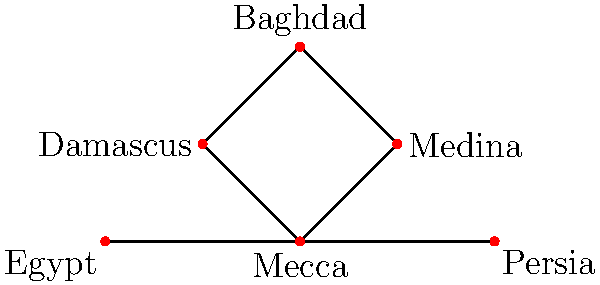In the graph representing the spread of early Islamic teachings, what is the minimum number of cities that need to be removed to disconnect Mecca from Baghdad? To solve this problem, we need to analyze the graph and find the minimum cut between Mecca and Baghdad. Let's approach this step-by-step:

1. Identify the paths from Mecca to Baghdad:
   a. Mecca → Medina → Baghdad
   b. Mecca → Damascus → Baghdad

2. Observe that there are two independent paths from Mecca to Baghdad.

3. According to Menger's theorem, the minimum number of vertices that need to be removed to disconnect two non-adjacent vertices is equal to the maximum number of vertex-disjoint paths between them.

4. In this case, we have two vertex-disjoint paths from Mecca to Baghdad.

5. Therefore, we need to remove at least two cities to disconnect Mecca from Baghdad.

6. The two cities that can be removed are:
   - Medina and Damascus
   OR
   - Any two cities from the set {Medina, Damascus, Baghdad}

7. Removing any single city would not be sufficient, as there would still be a path from Mecca to Baghdad.

Thus, the minimum number of cities that need to be removed to disconnect Mecca from Baghdad is 2.
Answer: 2 